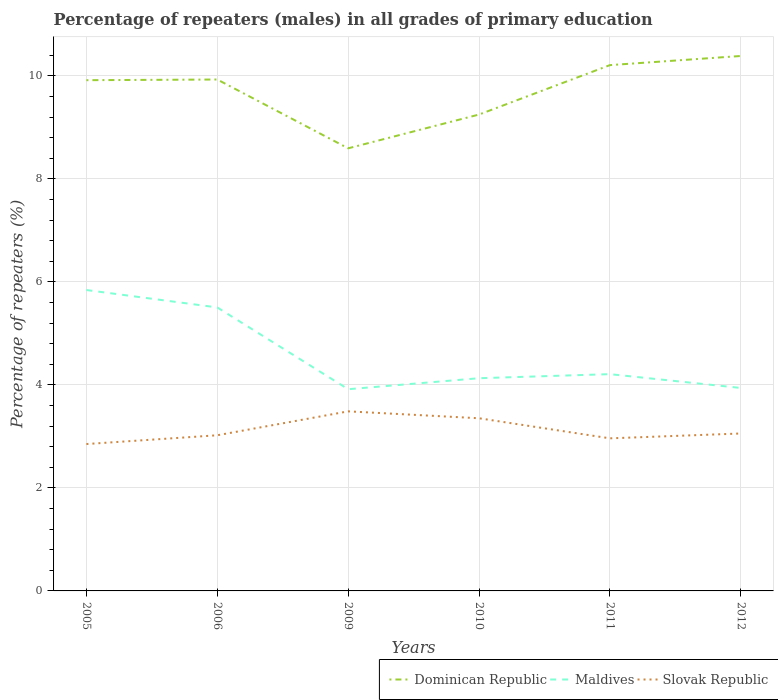Does the line corresponding to Maldives intersect with the line corresponding to Slovak Republic?
Provide a succinct answer. No. Is the number of lines equal to the number of legend labels?
Keep it short and to the point. Yes. Across all years, what is the maximum percentage of repeaters (males) in Maldives?
Offer a very short reply. 3.92. What is the total percentage of repeaters (males) in Maldives in the graph?
Your answer should be very brief. -0.08. What is the difference between the highest and the second highest percentage of repeaters (males) in Dominican Republic?
Offer a terse response. 1.79. Does the graph contain any zero values?
Your answer should be very brief. No. Does the graph contain grids?
Your answer should be very brief. Yes. Where does the legend appear in the graph?
Keep it short and to the point. Bottom right. How many legend labels are there?
Offer a terse response. 3. What is the title of the graph?
Make the answer very short. Percentage of repeaters (males) in all grades of primary education. Does "Botswana" appear as one of the legend labels in the graph?
Provide a short and direct response. No. What is the label or title of the X-axis?
Your answer should be very brief. Years. What is the label or title of the Y-axis?
Offer a very short reply. Percentage of repeaters (%). What is the Percentage of repeaters (%) of Dominican Republic in 2005?
Offer a very short reply. 9.92. What is the Percentage of repeaters (%) of Maldives in 2005?
Give a very brief answer. 5.84. What is the Percentage of repeaters (%) of Slovak Republic in 2005?
Keep it short and to the point. 2.85. What is the Percentage of repeaters (%) in Dominican Republic in 2006?
Ensure brevity in your answer.  9.93. What is the Percentage of repeaters (%) in Maldives in 2006?
Keep it short and to the point. 5.5. What is the Percentage of repeaters (%) in Slovak Republic in 2006?
Ensure brevity in your answer.  3.02. What is the Percentage of repeaters (%) in Dominican Republic in 2009?
Ensure brevity in your answer.  8.6. What is the Percentage of repeaters (%) in Maldives in 2009?
Give a very brief answer. 3.92. What is the Percentage of repeaters (%) of Slovak Republic in 2009?
Your answer should be compact. 3.49. What is the Percentage of repeaters (%) in Dominican Republic in 2010?
Offer a very short reply. 9.25. What is the Percentage of repeaters (%) of Maldives in 2010?
Provide a succinct answer. 4.13. What is the Percentage of repeaters (%) in Slovak Republic in 2010?
Provide a short and direct response. 3.35. What is the Percentage of repeaters (%) of Dominican Republic in 2011?
Offer a terse response. 10.21. What is the Percentage of repeaters (%) in Maldives in 2011?
Ensure brevity in your answer.  4.21. What is the Percentage of repeaters (%) of Slovak Republic in 2011?
Your answer should be compact. 2.96. What is the Percentage of repeaters (%) in Dominican Republic in 2012?
Your response must be concise. 10.39. What is the Percentage of repeaters (%) in Maldives in 2012?
Keep it short and to the point. 3.94. What is the Percentage of repeaters (%) of Slovak Republic in 2012?
Provide a succinct answer. 3.06. Across all years, what is the maximum Percentage of repeaters (%) of Dominican Republic?
Offer a very short reply. 10.39. Across all years, what is the maximum Percentage of repeaters (%) in Maldives?
Ensure brevity in your answer.  5.84. Across all years, what is the maximum Percentage of repeaters (%) of Slovak Republic?
Keep it short and to the point. 3.49. Across all years, what is the minimum Percentage of repeaters (%) in Dominican Republic?
Make the answer very short. 8.6. Across all years, what is the minimum Percentage of repeaters (%) of Maldives?
Offer a terse response. 3.92. Across all years, what is the minimum Percentage of repeaters (%) in Slovak Republic?
Your answer should be very brief. 2.85. What is the total Percentage of repeaters (%) of Dominican Republic in the graph?
Your answer should be compact. 58.29. What is the total Percentage of repeaters (%) in Maldives in the graph?
Ensure brevity in your answer.  27.55. What is the total Percentage of repeaters (%) of Slovak Republic in the graph?
Provide a succinct answer. 18.74. What is the difference between the Percentage of repeaters (%) in Dominican Republic in 2005 and that in 2006?
Keep it short and to the point. -0.01. What is the difference between the Percentage of repeaters (%) of Maldives in 2005 and that in 2006?
Ensure brevity in your answer.  0.34. What is the difference between the Percentage of repeaters (%) in Slovak Republic in 2005 and that in 2006?
Provide a short and direct response. -0.17. What is the difference between the Percentage of repeaters (%) of Dominican Republic in 2005 and that in 2009?
Ensure brevity in your answer.  1.32. What is the difference between the Percentage of repeaters (%) of Maldives in 2005 and that in 2009?
Offer a very short reply. 1.93. What is the difference between the Percentage of repeaters (%) in Slovak Republic in 2005 and that in 2009?
Provide a succinct answer. -0.63. What is the difference between the Percentage of repeaters (%) of Dominican Republic in 2005 and that in 2010?
Your answer should be compact. 0.67. What is the difference between the Percentage of repeaters (%) in Maldives in 2005 and that in 2010?
Keep it short and to the point. 1.71. What is the difference between the Percentage of repeaters (%) of Slovak Republic in 2005 and that in 2010?
Provide a short and direct response. -0.5. What is the difference between the Percentage of repeaters (%) in Dominican Republic in 2005 and that in 2011?
Provide a short and direct response. -0.29. What is the difference between the Percentage of repeaters (%) of Maldives in 2005 and that in 2011?
Provide a short and direct response. 1.63. What is the difference between the Percentage of repeaters (%) in Slovak Republic in 2005 and that in 2011?
Ensure brevity in your answer.  -0.11. What is the difference between the Percentage of repeaters (%) in Dominican Republic in 2005 and that in 2012?
Offer a very short reply. -0.47. What is the difference between the Percentage of repeaters (%) in Maldives in 2005 and that in 2012?
Provide a short and direct response. 1.9. What is the difference between the Percentage of repeaters (%) of Slovak Republic in 2005 and that in 2012?
Provide a succinct answer. -0.2. What is the difference between the Percentage of repeaters (%) in Dominican Republic in 2006 and that in 2009?
Your answer should be very brief. 1.34. What is the difference between the Percentage of repeaters (%) of Maldives in 2006 and that in 2009?
Keep it short and to the point. 1.59. What is the difference between the Percentage of repeaters (%) in Slovak Republic in 2006 and that in 2009?
Ensure brevity in your answer.  -0.46. What is the difference between the Percentage of repeaters (%) in Dominican Republic in 2006 and that in 2010?
Give a very brief answer. 0.68. What is the difference between the Percentage of repeaters (%) in Maldives in 2006 and that in 2010?
Make the answer very short. 1.37. What is the difference between the Percentage of repeaters (%) in Slovak Republic in 2006 and that in 2010?
Your answer should be compact. -0.33. What is the difference between the Percentage of repeaters (%) of Dominican Republic in 2006 and that in 2011?
Ensure brevity in your answer.  -0.28. What is the difference between the Percentage of repeaters (%) in Maldives in 2006 and that in 2011?
Your answer should be very brief. 1.3. What is the difference between the Percentage of repeaters (%) of Slovak Republic in 2006 and that in 2011?
Offer a terse response. 0.06. What is the difference between the Percentage of repeaters (%) in Dominican Republic in 2006 and that in 2012?
Ensure brevity in your answer.  -0.46. What is the difference between the Percentage of repeaters (%) of Maldives in 2006 and that in 2012?
Offer a very short reply. 1.56. What is the difference between the Percentage of repeaters (%) in Slovak Republic in 2006 and that in 2012?
Keep it short and to the point. -0.03. What is the difference between the Percentage of repeaters (%) in Dominican Republic in 2009 and that in 2010?
Make the answer very short. -0.66. What is the difference between the Percentage of repeaters (%) in Maldives in 2009 and that in 2010?
Give a very brief answer. -0.21. What is the difference between the Percentage of repeaters (%) of Slovak Republic in 2009 and that in 2010?
Keep it short and to the point. 0.13. What is the difference between the Percentage of repeaters (%) of Dominican Republic in 2009 and that in 2011?
Your response must be concise. -1.62. What is the difference between the Percentage of repeaters (%) of Maldives in 2009 and that in 2011?
Your answer should be very brief. -0.29. What is the difference between the Percentage of repeaters (%) of Slovak Republic in 2009 and that in 2011?
Give a very brief answer. 0.52. What is the difference between the Percentage of repeaters (%) in Dominican Republic in 2009 and that in 2012?
Provide a short and direct response. -1.79. What is the difference between the Percentage of repeaters (%) of Maldives in 2009 and that in 2012?
Your answer should be compact. -0.02. What is the difference between the Percentage of repeaters (%) in Slovak Republic in 2009 and that in 2012?
Provide a short and direct response. 0.43. What is the difference between the Percentage of repeaters (%) in Dominican Republic in 2010 and that in 2011?
Ensure brevity in your answer.  -0.96. What is the difference between the Percentage of repeaters (%) in Maldives in 2010 and that in 2011?
Ensure brevity in your answer.  -0.08. What is the difference between the Percentage of repeaters (%) of Slovak Republic in 2010 and that in 2011?
Your answer should be very brief. 0.39. What is the difference between the Percentage of repeaters (%) in Dominican Republic in 2010 and that in 2012?
Offer a very short reply. -1.14. What is the difference between the Percentage of repeaters (%) in Maldives in 2010 and that in 2012?
Make the answer very short. 0.19. What is the difference between the Percentage of repeaters (%) of Slovak Republic in 2010 and that in 2012?
Your answer should be compact. 0.3. What is the difference between the Percentage of repeaters (%) of Dominican Republic in 2011 and that in 2012?
Make the answer very short. -0.18. What is the difference between the Percentage of repeaters (%) of Maldives in 2011 and that in 2012?
Your answer should be compact. 0.27. What is the difference between the Percentage of repeaters (%) in Slovak Republic in 2011 and that in 2012?
Your response must be concise. -0.09. What is the difference between the Percentage of repeaters (%) of Dominican Republic in 2005 and the Percentage of repeaters (%) of Maldives in 2006?
Give a very brief answer. 4.41. What is the difference between the Percentage of repeaters (%) in Dominican Republic in 2005 and the Percentage of repeaters (%) in Slovak Republic in 2006?
Your answer should be very brief. 6.9. What is the difference between the Percentage of repeaters (%) of Maldives in 2005 and the Percentage of repeaters (%) of Slovak Republic in 2006?
Offer a very short reply. 2.82. What is the difference between the Percentage of repeaters (%) in Dominican Republic in 2005 and the Percentage of repeaters (%) in Maldives in 2009?
Provide a short and direct response. 6. What is the difference between the Percentage of repeaters (%) in Dominican Republic in 2005 and the Percentage of repeaters (%) in Slovak Republic in 2009?
Offer a very short reply. 6.43. What is the difference between the Percentage of repeaters (%) of Maldives in 2005 and the Percentage of repeaters (%) of Slovak Republic in 2009?
Your answer should be compact. 2.36. What is the difference between the Percentage of repeaters (%) of Dominican Republic in 2005 and the Percentage of repeaters (%) of Maldives in 2010?
Make the answer very short. 5.79. What is the difference between the Percentage of repeaters (%) of Dominican Republic in 2005 and the Percentage of repeaters (%) of Slovak Republic in 2010?
Provide a succinct answer. 6.57. What is the difference between the Percentage of repeaters (%) in Maldives in 2005 and the Percentage of repeaters (%) in Slovak Republic in 2010?
Ensure brevity in your answer.  2.49. What is the difference between the Percentage of repeaters (%) of Dominican Republic in 2005 and the Percentage of repeaters (%) of Maldives in 2011?
Your response must be concise. 5.71. What is the difference between the Percentage of repeaters (%) in Dominican Republic in 2005 and the Percentage of repeaters (%) in Slovak Republic in 2011?
Your answer should be very brief. 6.95. What is the difference between the Percentage of repeaters (%) in Maldives in 2005 and the Percentage of repeaters (%) in Slovak Republic in 2011?
Your answer should be very brief. 2.88. What is the difference between the Percentage of repeaters (%) of Dominican Republic in 2005 and the Percentage of repeaters (%) of Maldives in 2012?
Provide a short and direct response. 5.98. What is the difference between the Percentage of repeaters (%) of Dominican Republic in 2005 and the Percentage of repeaters (%) of Slovak Republic in 2012?
Offer a terse response. 6.86. What is the difference between the Percentage of repeaters (%) in Maldives in 2005 and the Percentage of repeaters (%) in Slovak Republic in 2012?
Ensure brevity in your answer.  2.79. What is the difference between the Percentage of repeaters (%) in Dominican Republic in 2006 and the Percentage of repeaters (%) in Maldives in 2009?
Provide a succinct answer. 6.01. What is the difference between the Percentage of repeaters (%) of Dominican Republic in 2006 and the Percentage of repeaters (%) of Slovak Republic in 2009?
Your response must be concise. 6.44. What is the difference between the Percentage of repeaters (%) of Maldives in 2006 and the Percentage of repeaters (%) of Slovak Republic in 2009?
Keep it short and to the point. 2.02. What is the difference between the Percentage of repeaters (%) of Dominican Republic in 2006 and the Percentage of repeaters (%) of Maldives in 2010?
Your answer should be very brief. 5.8. What is the difference between the Percentage of repeaters (%) in Dominican Republic in 2006 and the Percentage of repeaters (%) in Slovak Republic in 2010?
Keep it short and to the point. 6.58. What is the difference between the Percentage of repeaters (%) of Maldives in 2006 and the Percentage of repeaters (%) of Slovak Republic in 2010?
Ensure brevity in your answer.  2.15. What is the difference between the Percentage of repeaters (%) of Dominican Republic in 2006 and the Percentage of repeaters (%) of Maldives in 2011?
Provide a succinct answer. 5.72. What is the difference between the Percentage of repeaters (%) in Dominican Republic in 2006 and the Percentage of repeaters (%) in Slovak Republic in 2011?
Offer a terse response. 6.97. What is the difference between the Percentage of repeaters (%) of Maldives in 2006 and the Percentage of repeaters (%) of Slovak Republic in 2011?
Provide a short and direct response. 2.54. What is the difference between the Percentage of repeaters (%) in Dominican Republic in 2006 and the Percentage of repeaters (%) in Maldives in 2012?
Your response must be concise. 5.99. What is the difference between the Percentage of repeaters (%) of Dominican Republic in 2006 and the Percentage of repeaters (%) of Slovak Republic in 2012?
Your answer should be compact. 6.87. What is the difference between the Percentage of repeaters (%) of Maldives in 2006 and the Percentage of repeaters (%) of Slovak Republic in 2012?
Your response must be concise. 2.45. What is the difference between the Percentage of repeaters (%) of Dominican Republic in 2009 and the Percentage of repeaters (%) of Maldives in 2010?
Your response must be concise. 4.46. What is the difference between the Percentage of repeaters (%) of Dominican Republic in 2009 and the Percentage of repeaters (%) of Slovak Republic in 2010?
Provide a short and direct response. 5.24. What is the difference between the Percentage of repeaters (%) of Maldives in 2009 and the Percentage of repeaters (%) of Slovak Republic in 2010?
Make the answer very short. 0.56. What is the difference between the Percentage of repeaters (%) in Dominican Republic in 2009 and the Percentage of repeaters (%) in Maldives in 2011?
Give a very brief answer. 4.39. What is the difference between the Percentage of repeaters (%) in Dominican Republic in 2009 and the Percentage of repeaters (%) in Slovak Republic in 2011?
Your answer should be compact. 5.63. What is the difference between the Percentage of repeaters (%) in Maldives in 2009 and the Percentage of repeaters (%) in Slovak Republic in 2011?
Your answer should be compact. 0.95. What is the difference between the Percentage of repeaters (%) of Dominican Republic in 2009 and the Percentage of repeaters (%) of Maldives in 2012?
Your answer should be very brief. 4.65. What is the difference between the Percentage of repeaters (%) in Dominican Republic in 2009 and the Percentage of repeaters (%) in Slovak Republic in 2012?
Make the answer very short. 5.54. What is the difference between the Percentage of repeaters (%) in Maldives in 2009 and the Percentage of repeaters (%) in Slovak Republic in 2012?
Offer a very short reply. 0.86. What is the difference between the Percentage of repeaters (%) in Dominican Republic in 2010 and the Percentage of repeaters (%) in Maldives in 2011?
Provide a succinct answer. 5.04. What is the difference between the Percentage of repeaters (%) in Dominican Republic in 2010 and the Percentage of repeaters (%) in Slovak Republic in 2011?
Your answer should be very brief. 6.29. What is the difference between the Percentage of repeaters (%) in Maldives in 2010 and the Percentage of repeaters (%) in Slovak Republic in 2011?
Provide a short and direct response. 1.17. What is the difference between the Percentage of repeaters (%) in Dominican Republic in 2010 and the Percentage of repeaters (%) in Maldives in 2012?
Your answer should be very brief. 5.31. What is the difference between the Percentage of repeaters (%) of Dominican Republic in 2010 and the Percentage of repeaters (%) of Slovak Republic in 2012?
Ensure brevity in your answer.  6.19. What is the difference between the Percentage of repeaters (%) of Maldives in 2010 and the Percentage of repeaters (%) of Slovak Republic in 2012?
Offer a terse response. 1.07. What is the difference between the Percentage of repeaters (%) of Dominican Republic in 2011 and the Percentage of repeaters (%) of Maldives in 2012?
Offer a terse response. 6.27. What is the difference between the Percentage of repeaters (%) of Dominican Republic in 2011 and the Percentage of repeaters (%) of Slovak Republic in 2012?
Your answer should be very brief. 7.15. What is the difference between the Percentage of repeaters (%) in Maldives in 2011 and the Percentage of repeaters (%) in Slovak Republic in 2012?
Ensure brevity in your answer.  1.15. What is the average Percentage of repeaters (%) of Dominican Republic per year?
Provide a succinct answer. 9.72. What is the average Percentage of repeaters (%) of Maldives per year?
Your response must be concise. 4.59. What is the average Percentage of repeaters (%) in Slovak Republic per year?
Keep it short and to the point. 3.12. In the year 2005, what is the difference between the Percentage of repeaters (%) of Dominican Republic and Percentage of repeaters (%) of Maldives?
Provide a short and direct response. 4.07. In the year 2005, what is the difference between the Percentage of repeaters (%) in Dominican Republic and Percentage of repeaters (%) in Slovak Republic?
Your answer should be compact. 7.07. In the year 2005, what is the difference between the Percentage of repeaters (%) in Maldives and Percentage of repeaters (%) in Slovak Republic?
Offer a very short reply. 2.99. In the year 2006, what is the difference between the Percentage of repeaters (%) of Dominican Republic and Percentage of repeaters (%) of Maldives?
Give a very brief answer. 4.43. In the year 2006, what is the difference between the Percentage of repeaters (%) in Dominican Republic and Percentage of repeaters (%) in Slovak Republic?
Provide a succinct answer. 6.91. In the year 2006, what is the difference between the Percentage of repeaters (%) in Maldives and Percentage of repeaters (%) in Slovak Republic?
Offer a very short reply. 2.48. In the year 2009, what is the difference between the Percentage of repeaters (%) of Dominican Republic and Percentage of repeaters (%) of Maldives?
Keep it short and to the point. 4.68. In the year 2009, what is the difference between the Percentage of repeaters (%) of Dominican Republic and Percentage of repeaters (%) of Slovak Republic?
Offer a terse response. 5.11. In the year 2009, what is the difference between the Percentage of repeaters (%) of Maldives and Percentage of repeaters (%) of Slovak Republic?
Provide a succinct answer. 0.43. In the year 2010, what is the difference between the Percentage of repeaters (%) in Dominican Republic and Percentage of repeaters (%) in Maldives?
Your answer should be very brief. 5.12. In the year 2010, what is the difference between the Percentage of repeaters (%) of Dominican Republic and Percentage of repeaters (%) of Slovak Republic?
Your answer should be very brief. 5.9. In the year 2010, what is the difference between the Percentage of repeaters (%) in Maldives and Percentage of repeaters (%) in Slovak Republic?
Ensure brevity in your answer.  0.78. In the year 2011, what is the difference between the Percentage of repeaters (%) in Dominican Republic and Percentage of repeaters (%) in Maldives?
Your response must be concise. 6. In the year 2011, what is the difference between the Percentage of repeaters (%) of Dominican Republic and Percentage of repeaters (%) of Slovak Republic?
Provide a succinct answer. 7.25. In the year 2011, what is the difference between the Percentage of repeaters (%) in Maldives and Percentage of repeaters (%) in Slovak Republic?
Provide a succinct answer. 1.25. In the year 2012, what is the difference between the Percentage of repeaters (%) of Dominican Republic and Percentage of repeaters (%) of Maldives?
Your answer should be very brief. 6.45. In the year 2012, what is the difference between the Percentage of repeaters (%) of Dominican Republic and Percentage of repeaters (%) of Slovak Republic?
Your answer should be very brief. 7.33. In the year 2012, what is the difference between the Percentage of repeaters (%) of Maldives and Percentage of repeaters (%) of Slovak Republic?
Provide a succinct answer. 0.88. What is the ratio of the Percentage of repeaters (%) in Dominican Republic in 2005 to that in 2006?
Make the answer very short. 1. What is the ratio of the Percentage of repeaters (%) in Maldives in 2005 to that in 2006?
Your answer should be compact. 1.06. What is the ratio of the Percentage of repeaters (%) in Slovak Republic in 2005 to that in 2006?
Your answer should be very brief. 0.94. What is the ratio of the Percentage of repeaters (%) in Dominican Republic in 2005 to that in 2009?
Your answer should be compact. 1.15. What is the ratio of the Percentage of repeaters (%) of Maldives in 2005 to that in 2009?
Your answer should be compact. 1.49. What is the ratio of the Percentage of repeaters (%) of Slovak Republic in 2005 to that in 2009?
Provide a short and direct response. 0.82. What is the ratio of the Percentage of repeaters (%) in Dominican Republic in 2005 to that in 2010?
Make the answer very short. 1.07. What is the ratio of the Percentage of repeaters (%) of Maldives in 2005 to that in 2010?
Provide a succinct answer. 1.41. What is the ratio of the Percentage of repeaters (%) of Slovak Republic in 2005 to that in 2010?
Provide a succinct answer. 0.85. What is the ratio of the Percentage of repeaters (%) in Dominican Republic in 2005 to that in 2011?
Provide a succinct answer. 0.97. What is the ratio of the Percentage of repeaters (%) of Maldives in 2005 to that in 2011?
Your answer should be very brief. 1.39. What is the ratio of the Percentage of repeaters (%) in Slovak Republic in 2005 to that in 2011?
Offer a very short reply. 0.96. What is the ratio of the Percentage of repeaters (%) in Dominican Republic in 2005 to that in 2012?
Offer a very short reply. 0.95. What is the ratio of the Percentage of repeaters (%) of Maldives in 2005 to that in 2012?
Your answer should be compact. 1.48. What is the ratio of the Percentage of repeaters (%) of Slovak Republic in 2005 to that in 2012?
Make the answer very short. 0.93. What is the ratio of the Percentage of repeaters (%) in Dominican Republic in 2006 to that in 2009?
Make the answer very short. 1.16. What is the ratio of the Percentage of repeaters (%) of Maldives in 2006 to that in 2009?
Keep it short and to the point. 1.41. What is the ratio of the Percentage of repeaters (%) in Slovak Republic in 2006 to that in 2009?
Your answer should be compact. 0.87. What is the ratio of the Percentage of repeaters (%) in Dominican Republic in 2006 to that in 2010?
Make the answer very short. 1.07. What is the ratio of the Percentage of repeaters (%) in Maldives in 2006 to that in 2010?
Provide a succinct answer. 1.33. What is the ratio of the Percentage of repeaters (%) in Slovak Republic in 2006 to that in 2010?
Give a very brief answer. 0.9. What is the ratio of the Percentage of repeaters (%) of Dominican Republic in 2006 to that in 2011?
Offer a terse response. 0.97. What is the ratio of the Percentage of repeaters (%) of Maldives in 2006 to that in 2011?
Offer a very short reply. 1.31. What is the ratio of the Percentage of repeaters (%) in Slovak Republic in 2006 to that in 2011?
Make the answer very short. 1.02. What is the ratio of the Percentage of repeaters (%) of Dominican Republic in 2006 to that in 2012?
Your response must be concise. 0.96. What is the ratio of the Percentage of repeaters (%) in Maldives in 2006 to that in 2012?
Your answer should be very brief. 1.4. What is the ratio of the Percentage of repeaters (%) of Slovak Republic in 2006 to that in 2012?
Make the answer very short. 0.99. What is the ratio of the Percentage of repeaters (%) of Dominican Republic in 2009 to that in 2010?
Your response must be concise. 0.93. What is the ratio of the Percentage of repeaters (%) in Maldives in 2009 to that in 2010?
Ensure brevity in your answer.  0.95. What is the ratio of the Percentage of repeaters (%) in Dominican Republic in 2009 to that in 2011?
Ensure brevity in your answer.  0.84. What is the ratio of the Percentage of repeaters (%) of Maldives in 2009 to that in 2011?
Keep it short and to the point. 0.93. What is the ratio of the Percentage of repeaters (%) in Slovak Republic in 2009 to that in 2011?
Provide a succinct answer. 1.18. What is the ratio of the Percentage of repeaters (%) of Dominican Republic in 2009 to that in 2012?
Your answer should be compact. 0.83. What is the ratio of the Percentage of repeaters (%) in Maldives in 2009 to that in 2012?
Provide a short and direct response. 0.99. What is the ratio of the Percentage of repeaters (%) of Slovak Republic in 2009 to that in 2012?
Make the answer very short. 1.14. What is the ratio of the Percentage of repeaters (%) of Dominican Republic in 2010 to that in 2011?
Your answer should be compact. 0.91. What is the ratio of the Percentage of repeaters (%) of Maldives in 2010 to that in 2011?
Ensure brevity in your answer.  0.98. What is the ratio of the Percentage of repeaters (%) in Slovak Republic in 2010 to that in 2011?
Your answer should be very brief. 1.13. What is the ratio of the Percentage of repeaters (%) of Dominican Republic in 2010 to that in 2012?
Provide a short and direct response. 0.89. What is the ratio of the Percentage of repeaters (%) in Maldives in 2010 to that in 2012?
Keep it short and to the point. 1.05. What is the ratio of the Percentage of repeaters (%) in Slovak Republic in 2010 to that in 2012?
Provide a succinct answer. 1.1. What is the ratio of the Percentage of repeaters (%) of Dominican Republic in 2011 to that in 2012?
Your response must be concise. 0.98. What is the ratio of the Percentage of repeaters (%) in Maldives in 2011 to that in 2012?
Your answer should be very brief. 1.07. What is the ratio of the Percentage of repeaters (%) of Slovak Republic in 2011 to that in 2012?
Give a very brief answer. 0.97. What is the difference between the highest and the second highest Percentage of repeaters (%) of Dominican Republic?
Your response must be concise. 0.18. What is the difference between the highest and the second highest Percentage of repeaters (%) of Maldives?
Your answer should be compact. 0.34. What is the difference between the highest and the second highest Percentage of repeaters (%) in Slovak Republic?
Your response must be concise. 0.13. What is the difference between the highest and the lowest Percentage of repeaters (%) in Dominican Republic?
Provide a short and direct response. 1.79. What is the difference between the highest and the lowest Percentage of repeaters (%) of Maldives?
Offer a terse response. 1.93. What is the difference between the highest and the lowest Percentage of repeaters (%) in Slovak Republic?
Offer a very short reply. 0.63. 